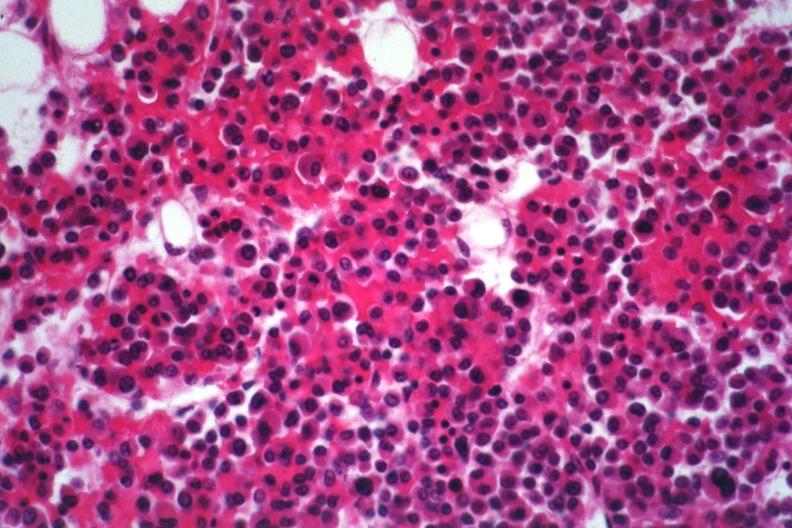s hematologic present?
Answer the question using a single word or phrase. Yes 